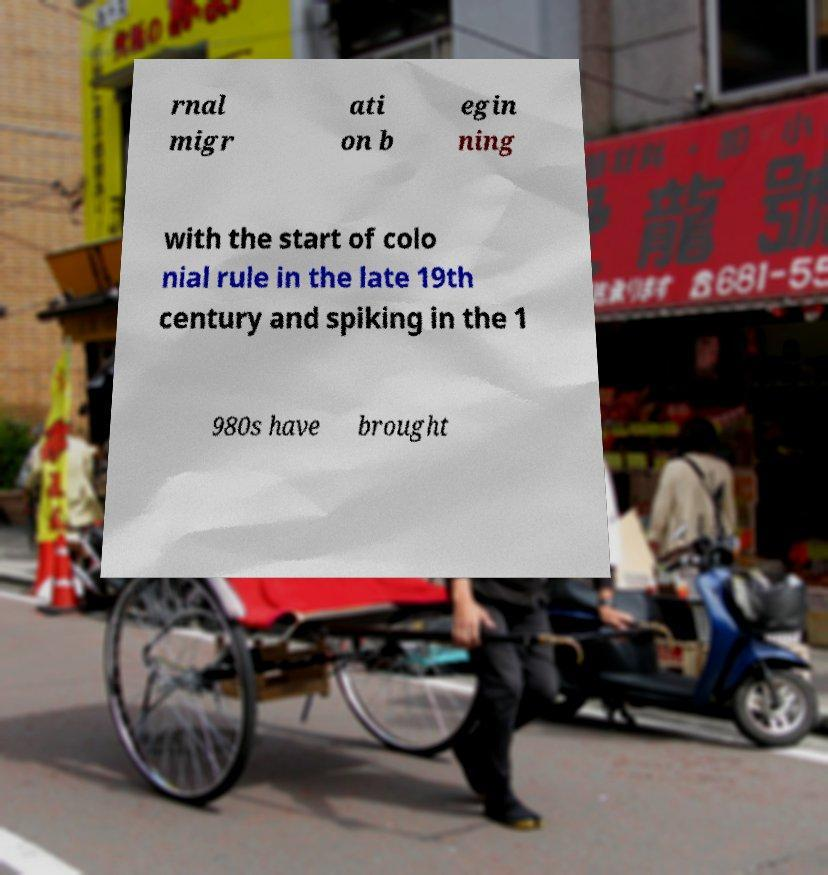I need the written content from this picture converted into text. Can you do that? rnal migr ati on b egin ning with the start of colo nial rule in the late 19th century and spiking in the 1 980s have brought 